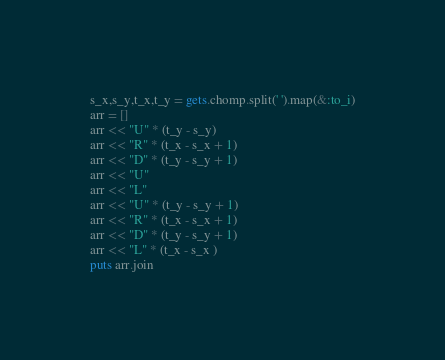<code> <loc_0><loc_0><loc_500><loc_500><_Ruby_>s_x,s_y,t_x,t_y = gets.chomp.split(' ').map(&:to_i)
arr = []
arr << "U" * (t_y - s_y)
arr << "R" * (t_x - s_x + 1)
arr << "D" * (t_y - s_y + 1)
arr << "U"
arr << "L"
arr << "U" * (t_y - s_y + 1)
arr << "R" * (t_x - s_x + 1)
arr << "D" * (t_y - s_y + 1)
arr << "L" * (t_x - s_x )
puts arr.join

</code> 